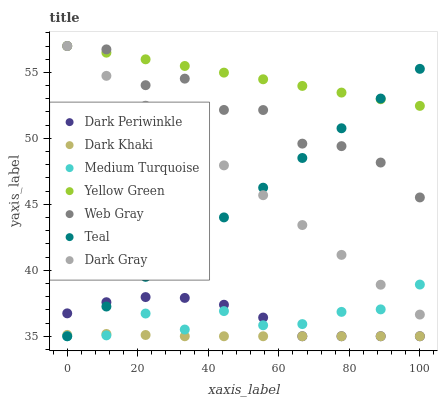Does Dark Khaki have the minimum area under the curve?
Answer yes or no. Yes. Does Yellow Green have the maximum area under the curve?
Answer yes or no. Yes. Does Web Gray have the minimum area under the curve?
Answer yes or no. No. Does Web Gray have the maximum area under the curve?
Answer yes or no. No. Is Yellow Green the smoothest?
Answer yes or no. Yes. Is Web Gray the roughest?
Answer yes or no. Yes. Is Medium Turquoise the smoothest?
Answer yes or no. No. Is Medium Turquoise the roughest?
Answer yes or no. No. Does Medium Turquoise have the lowest value?
Answer yes or no. Yes. Does Web Gray have the lowest value?
Answer yes or no. No. Does Yellow Green have the highest value?
Answer yes or no. Yes. Does Medium Turquoise have the highest value?
Answer yes or no. No. Is Dark Khaki less than Yellow Green?
Answer yes or no. Yes. Is Yellow Green greater than Medium Turquoise?
Answer yes or no. Yes. Does Web Gray intersect Dark Gray?
Answer yes or no. Yes. Is Web Gray less than Dark Gray?
Answer yes or no. No. Is Web Gray greater than Dark Gray?
Answer yes or no. No. Does Dark Khaki intersect Yellow Green?
Answer yes or no. No. 